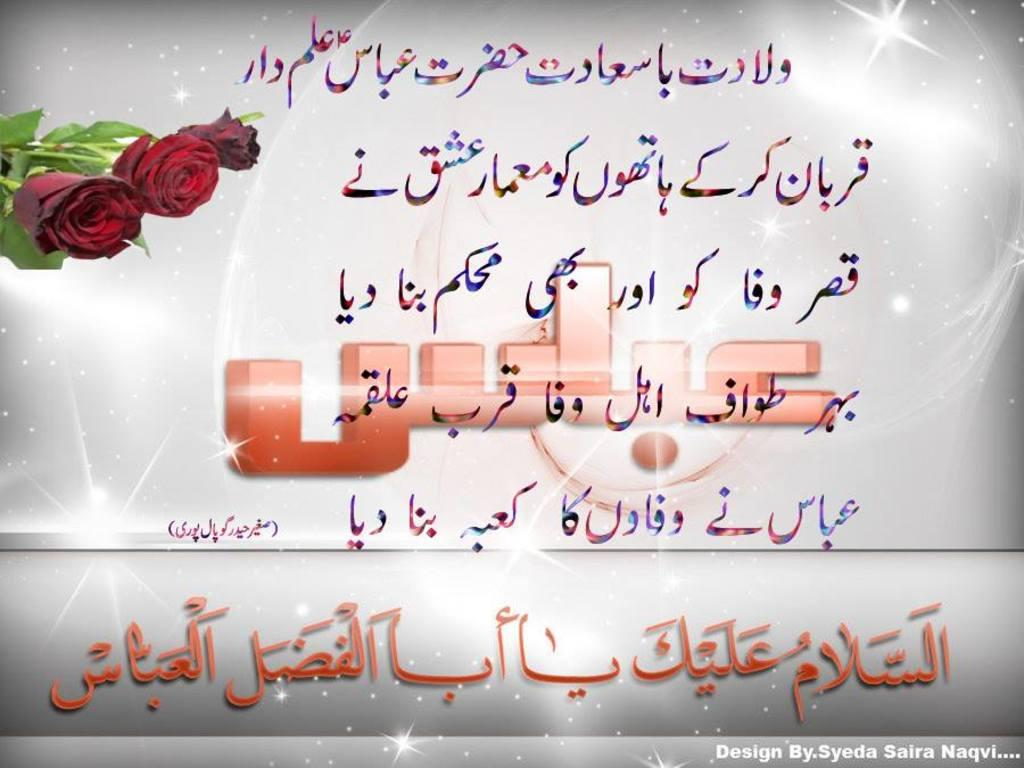What is the main object in the image? There is a poster in the image. Can you describe the appearance of the image? The image appears to be edited. What can be seen on the poster? There is text on the poster. What type of flowers are featured on the poster? Rose flowers are present on the poster. What song is being sung by the parent in the image? There is no parent or song present in the image; it features a poster with text and rose flowers. 